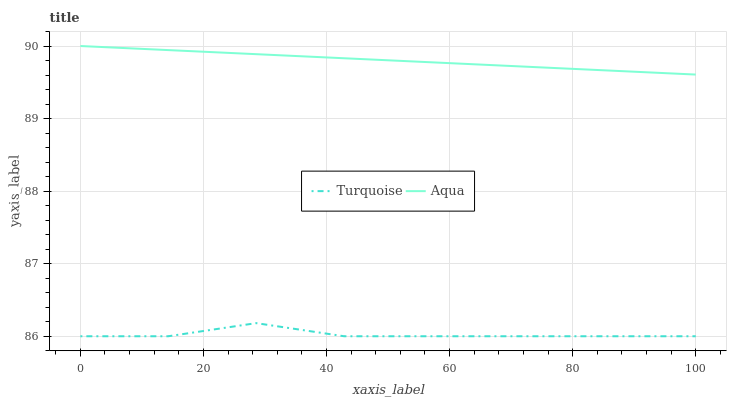Does Turquoise have the minimum area under the curve?
Answer yes or no. Yes. Does Aqua have the maximum area under the curve?
Answer yes or no. Yes. Does Aqua have the minimum area under the curve?
Answer yes or no. No. Is Aqua the smoothest?
Answer yes or no. Yes. Is Turquoise the roughest?
Answer yes or no. Yes. Is Aqua the roughest?
Answer yes or no. No. Does Turquoise have the lowest value?
Answer yes or no. Yes. Does Aqua have the lowest value?
Answer yes or no. No. Does Aqua have the highest value?
Answer yes or no. Yes. Is Turquoise less than Aqua?
Answer yes or no. Yes. Is Aqua greater than Turquoise?
Answer yes or no. Yes. Does Turquoise intersect Aqua?
Answer yes or no. No. 